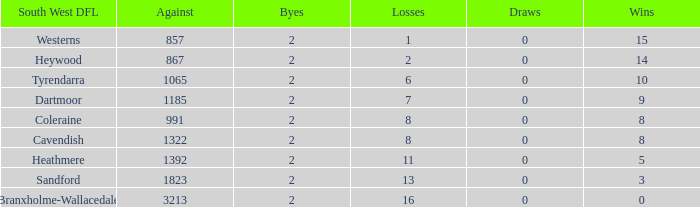In tyrendarra's south west dfl, how many draws have occurred with under 10 wins? None. 